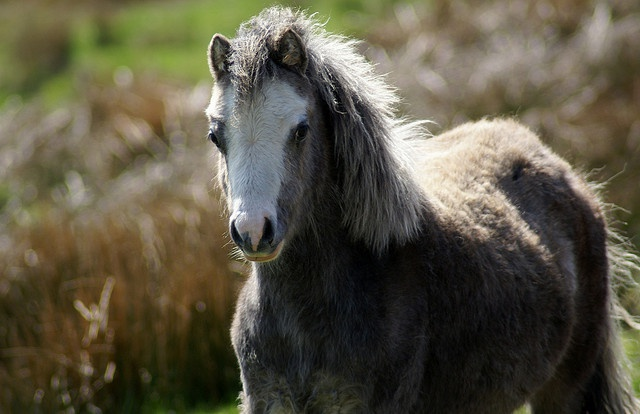Describe the objects in this image and their specific colors. I can see a horse in olive, black, gray, lightgray, and darkgray tones in this image. 